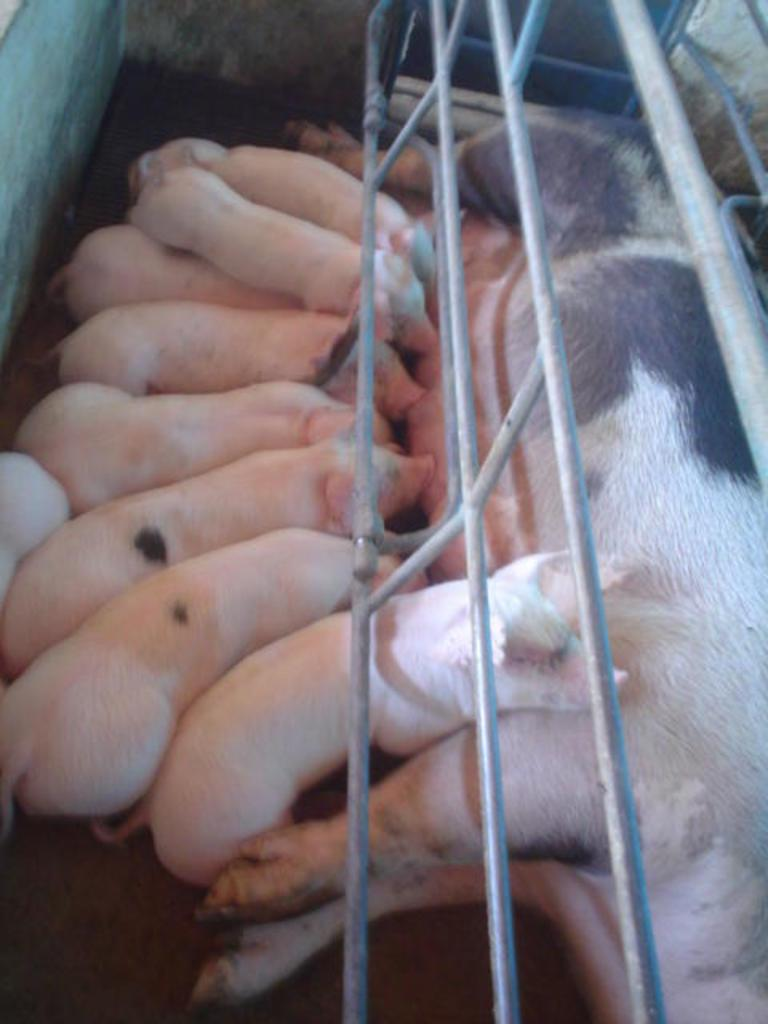What animal is present in the image? There is a pig in the image. What is the position of the pig in the image? The pig is lying on the ground. Are there any other pigs in the image? Yes, there are piglets in the image. What is the position of the piglets in the image? The piglets are lying on the ground. What type of ship can be seen in the image? There is no ship present in the image; it features a pig and piglets lying on the ground. How many babies are visible in the image? There are no babies present in the image; it features a pig and piglets, which are young pigs. 